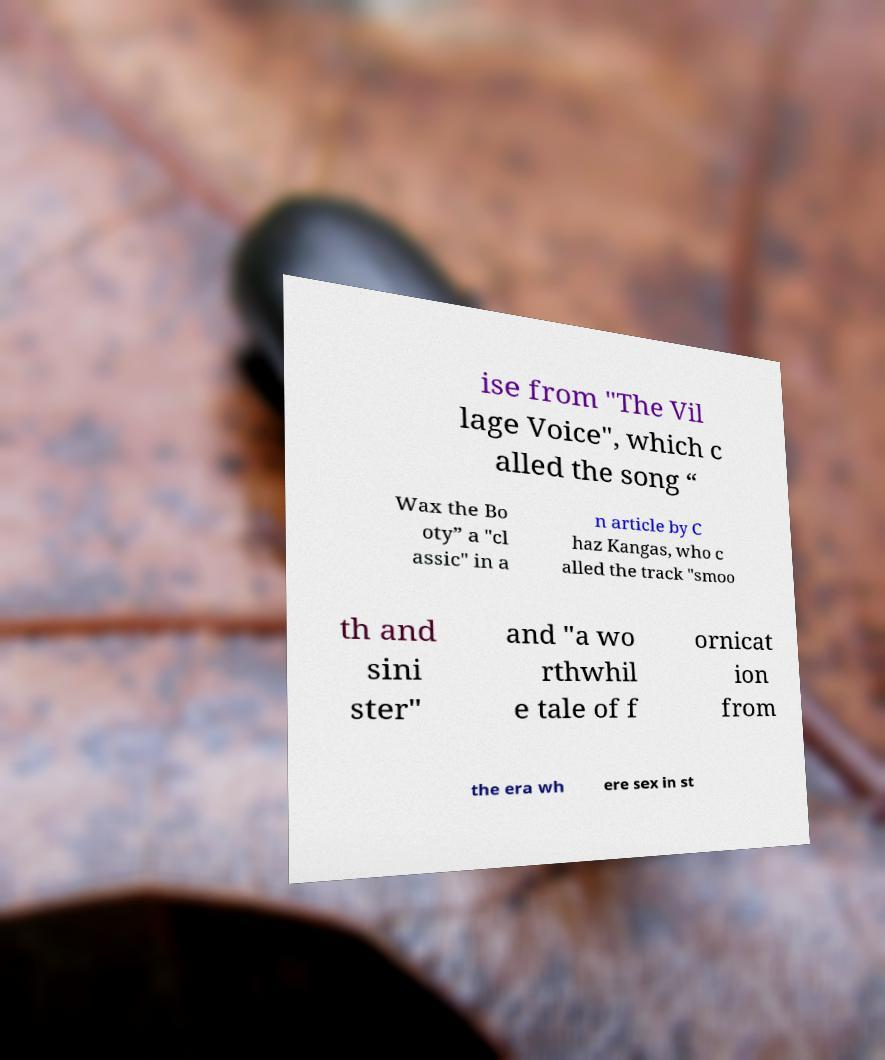What messages or text are displayed in this image? I need them in a readable, typed format. ise from "The Vil lage Voice", which c alled the song “ Wax the Bo oty” a "cl assic" in a n article by C haz Kangas, who c alled the track "smoo th and sini ster" and "a wo rthwhil e tale of f ornicat ion from the era wh ere sex in st 